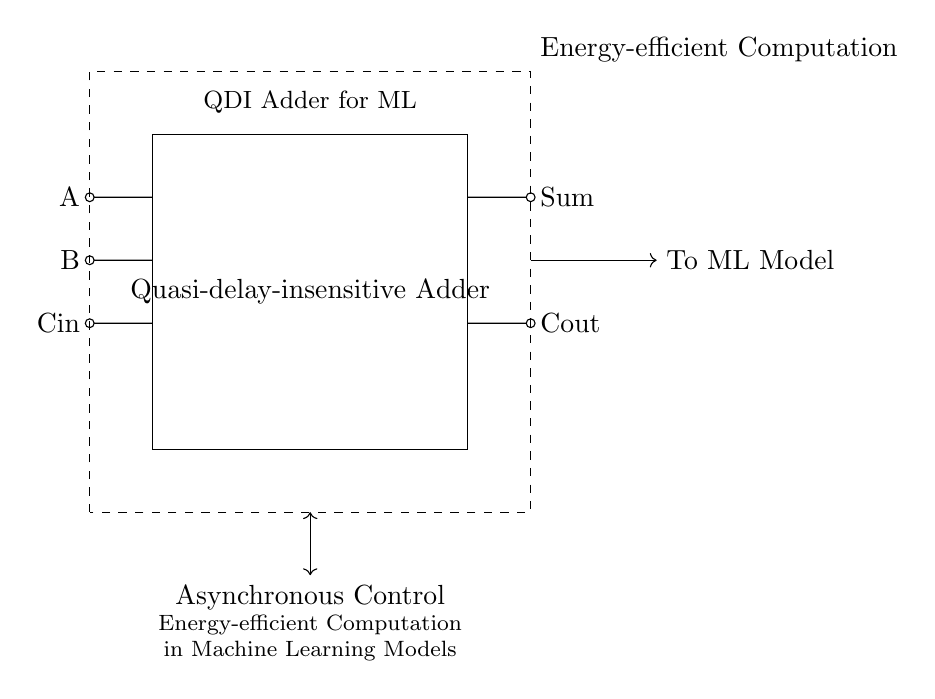What are the input signals to the adder? The input signals are A, B, and Cin, which are the three lines entering the adder block as indicated in the diagram.
Answer: A, B, Cin What is the function of the dashed rectangle in the diagram? The dashed rectangle represents the Energy-efficient Computation block, which encompasses the Quasi-delay-insensitive Adder and relates to its energy-efficient characteristics for machine learning applications.
Answer: Energy-efficient Computation What is the output of the adder? The outputs are labeled as Sum and Cout, which are the two resulting signals produced by the adder.
Answer: Sum, Cout What kind of control does the circuit use? The circuit uses Asynchronous Control, indicated by the bidirectional arrow labeled in the diagram, which signifies that operations can occur without a global clock signal.
Answer: Asynchronous Control Why is the adder classified as "quasi-delay-insensitive"? The adder is termed quasi-delay-insensitive because it operates correctly regardless of variations in delay, allowing it to perform reliably in environments where signal propagation times can fluctuate, which is vital in energy-efficient computations for machine learning.
Answer: Quasi-delay-insensitive What does the arrow leading to the ML model indicate? The arrow represents the flow of information or output from the Quasi-delay-insensitive Adder to the Machine Learning Model, indicating that the results are being utilized in the model.
Answer: To ML Model How is the adder block related to energy efficiency? The relationship is indicated by the block's design, as it is integrated within the larger Energy-efficient Computation block, suggesting that its operation helps reduce energy use in computational processes relevant to machine learning.
Answer: Energy-efficient Computation 